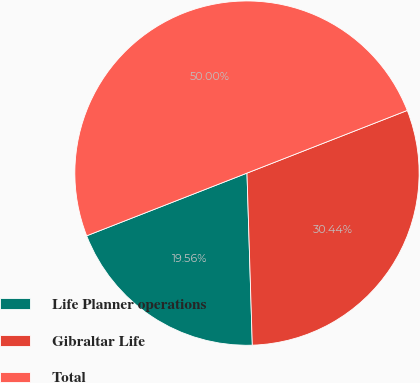Convert chart. <chart><loc_0><loc_0><loc_500><loc_500><pie_chart><fcel>Life Planner operations<fcel>Gibraltar Life<fcel>Total<nl><fcel>19.56%<fcel>30.44%<fcel>50.0%<nl></chart> 